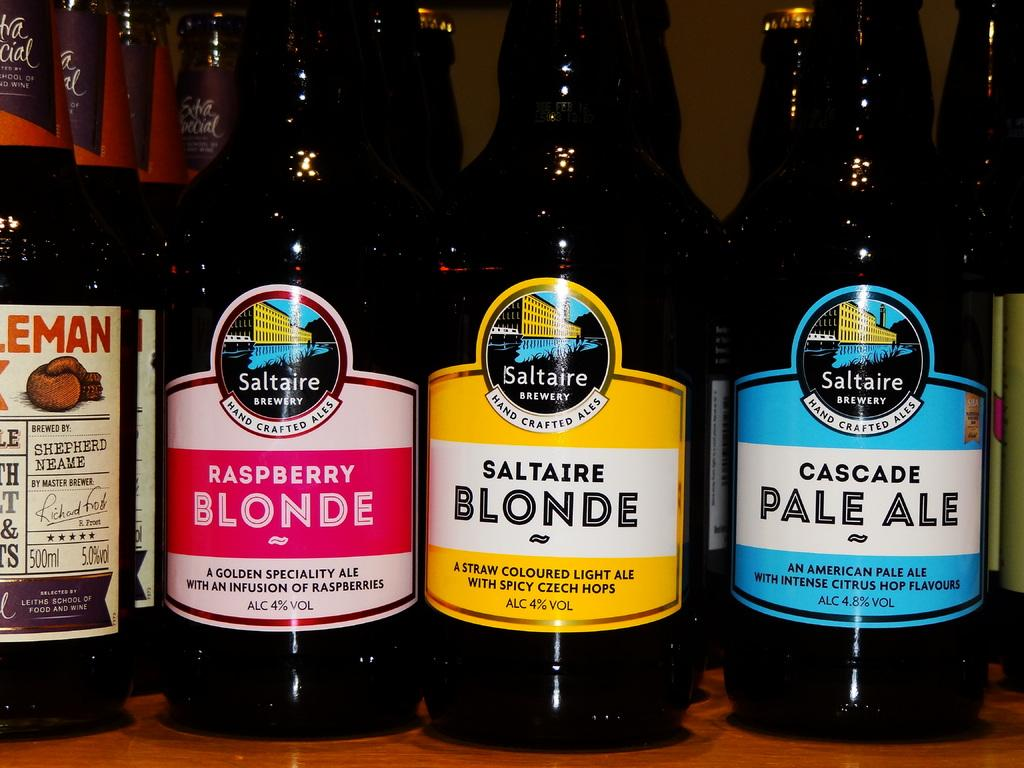<image>
Relay a brief, clear account of the picture shown. Lined up bottles of beverages in bottles called Saltaire Brewery hand crafted ale lined up on a bar shelf. 